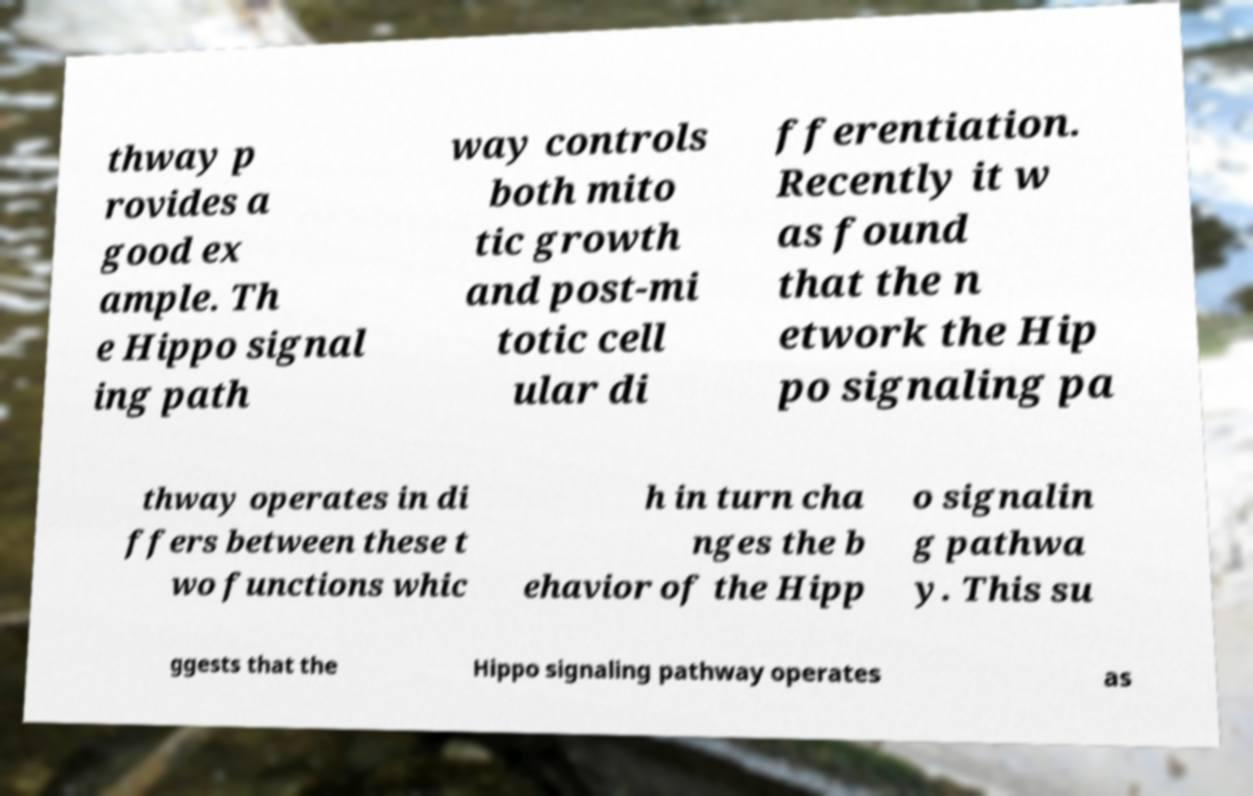Can you read and provide the text displayed in the image?This photo seems to have some interesting text. Can you extract and type it out for me? thway p rovides a good ex ample. Th e Hippo signal ing path way controls both mito tic growth and post-mi totic cell ular di fferentiation. Recently it w as found that the n etwork the Hip po signaling pa thway operates in di ffers between these t wo functions whic h in turn cha nges the b ehavior of the Hipp o signalin g pathwa y. This su ggests that the Hippo signaling pathway operates as 